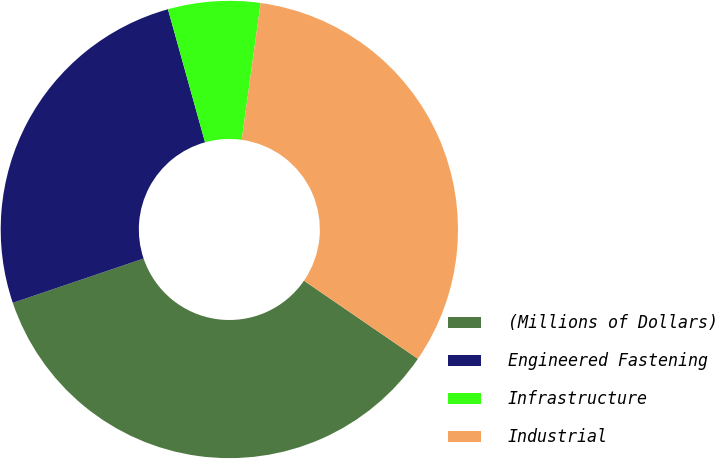Convert chart. <chart><loc_0><loc_0><loc_500><loc_500><pie_chart><fcel>(Millions of Dollars)<fcel>Engineered Fastening<fcel>Infrastructure<fcel>Industrial<nl><fcel>35.23%<fcel>25.87%<fcel>6.51%<fcel>32.38%<nl></chart> 